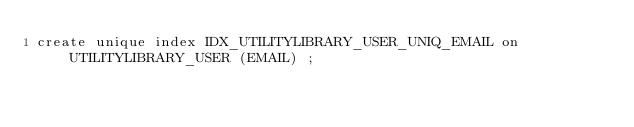Convert code to text. <code><loc_0><loc_0><loc_500><loc_500><_SQL_>create unique index IDX_UTILITYLIBRARY_USER_UNIQ_EMAIL on UTILITYLIBRARY_USER (EMAIL) ;
</code> 